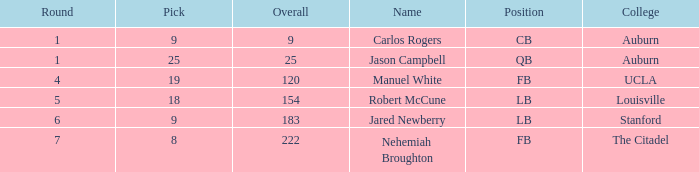Which university had a total selection of 9? Auburn. 